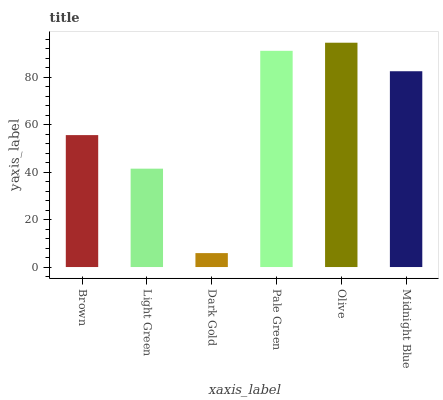Is Dark Gold the minimum?
Answer yes or no. Yes. Is Olive the maximum?
Answer yes or no. Yes. Is Light Green the minimum?
Answer yes or no. No. Is Light Green the maximum?
Answer yes or no. No. Is Brown greater than Light Green?
Answer yes or no. Yes. Is Light Green less than Brown?
Answer yes or no. Yes. Is Light Green greater than Brown?
Answer yes or no. No. Is Brown less than Light Green?
Answer yes or no. No. Is Midnight Blue the high median?
Answer yes or no. Yes. Is Brown the low median?
Answer yes or no. Yes. Is Brown the high median?
Answer yes or no. No. Is Midnight Blue the low median?
Answer yes or no. No. 